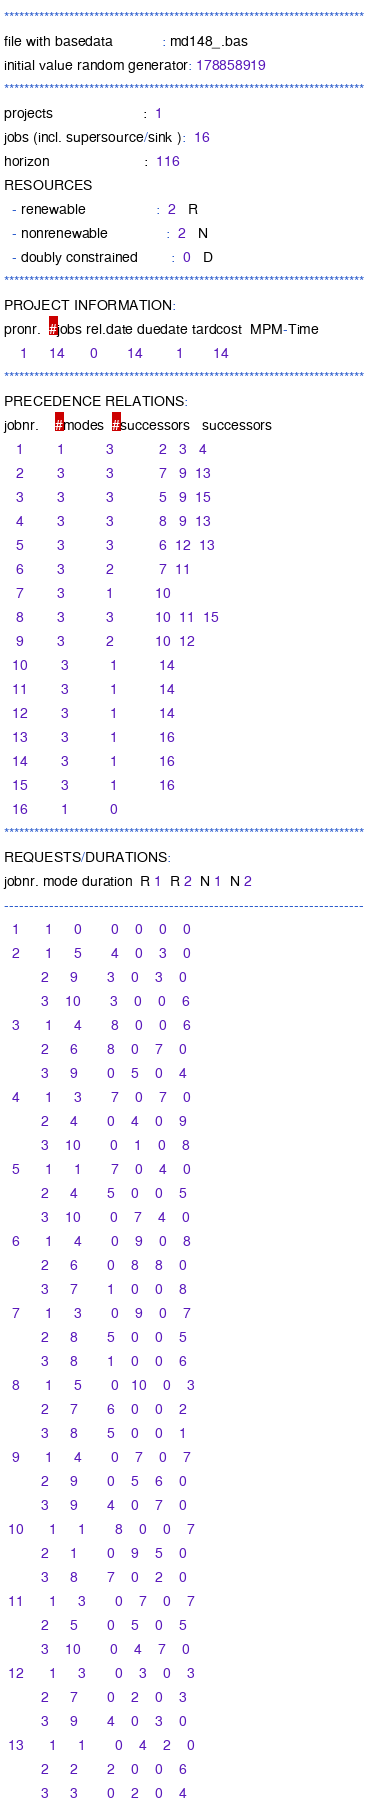Convert code to text. <code><loc_0><loc_0><loc_500><loc_500><_ObjectiveC_>************************************************************************
file with basedata            : md148_.bas
initial value random generator: 178858919
************************************************************************
projects                      :  1
jobs (incl. supersource/sink ):  16
horizon                       :  116
RESOURCES
  - renewable                 :  2   R
  - nonrenewable              :  2   N
  - doubly constrained        :  0   D
************************************************************************
PROJECT INFORMATION:
pronr.  #jobs rel.date duedate tardcost  MPM-Time
    1     14      0       14        1       14
************************************************************************
PRECEDENCE RELATIONS:
jobnr.    #modes  #successors   successors
   1        1          3           2   3   4
   2        3          3           7   9  13
   3        3          3           5   9  15
   4        3          3           8   9  13
   5        3          3           6  12  13
   6        3          2           7  11
   7        3          1          10
   8        3          3          10  11  15
   9        3          2          10  12
  10        3          1          14
  11        3          1          14
  12        3          1          14
  13        3          1          16
  14        3          1          16
  15        3          1          16
  16        1          0        
************************************************************************
REQUESTS/DURATIONS:
jobnr. mode duration  R 1  R 2  N 1  N 2
------------------------------------------------------------------------
  1      1     0       0    0    0    0
  2      1     5       4    0    3    0
         2     9       3    0    3    0
         3    10       3    0    0    6
  3      1     4       8    0    0    6
         2     6       8    0    7    0
         3     9       0    5    0    4
  4      1     3       7    0    7    0
         2     4       0    4    0    9
         3    10       0    1    0    8
  5      1     1       7    0    4    0
         2     4       5    0    0    5
         3    10       0    7    4    0
  6      1     4       0    9    0    8
         2     6       0    8    8    0
         3     7       1    0    0    8
  7      1     3       0    9    0    7
         2     8       5    0    0    5
         3     8       1    0    0    6
  8      1     5       0   10    0    3
         2     7       6    0    0    2
         3     8       5    0    0    1
  9      1     4       0    7    0    7
         2     9       0    5    6    0
         3     9       4    0    7    0
 10      1     1       8    0    0    7
         2     1       0    9    5    0
         3     8       7    0    2    0
 11      1     3       0    7    0    7
         2     5       0    5    0    5
         3    10       0    4    7    0
 12      1     3       0    3    0    3
         2     7       0    2    0    3
         3     9       4    0    3    0
 13      1     1       0    4    2    0
         2     2       2    0    0    6
         3     3       0    2    0    4</code> 